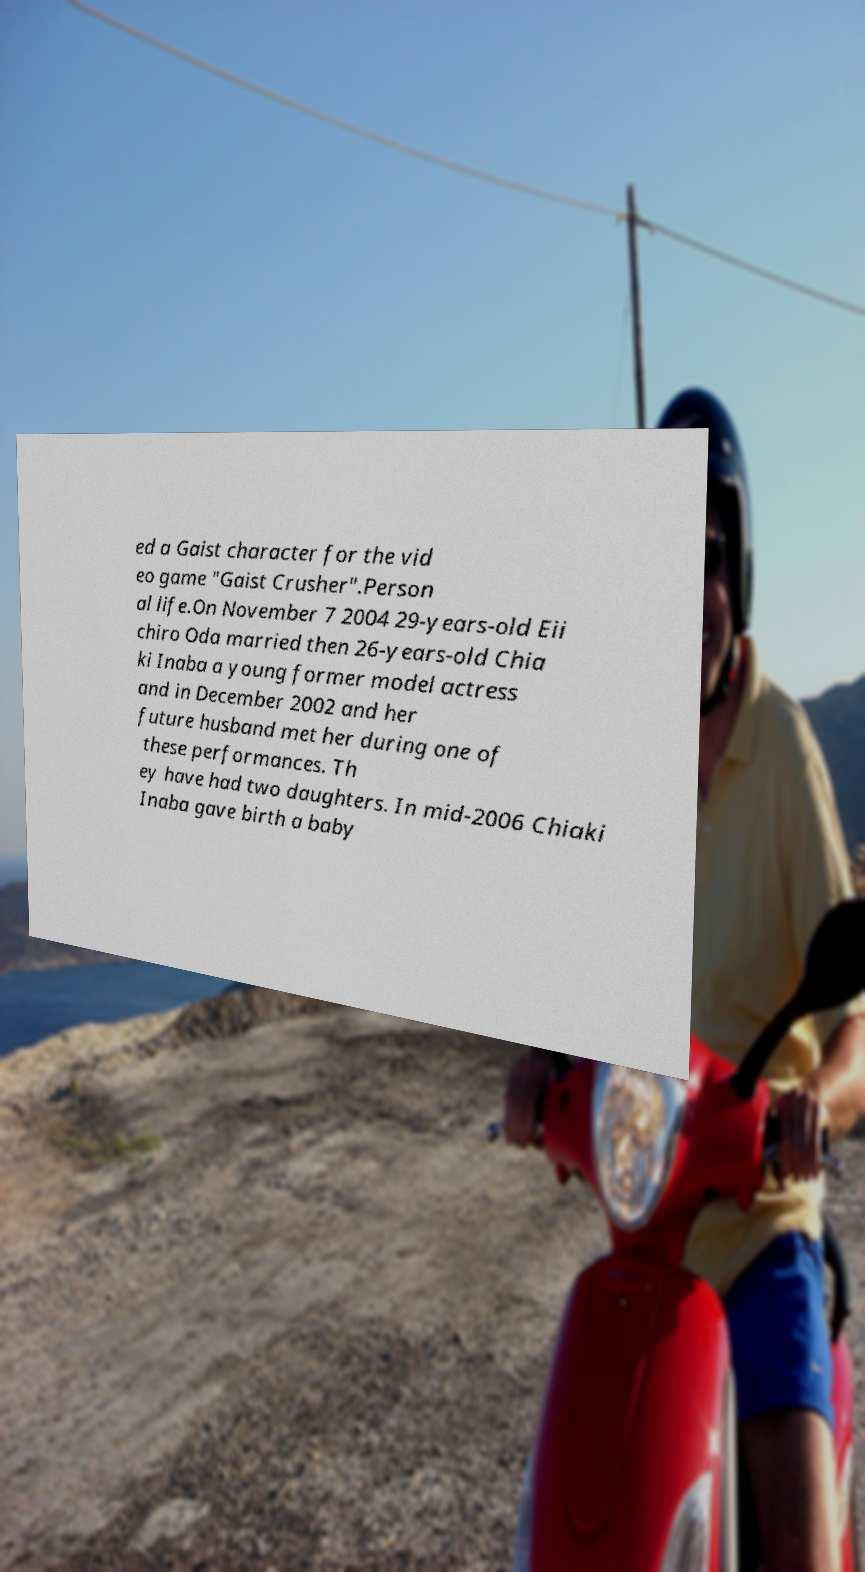Could you extract and type out the text from this image? ed a Gaist character for the vid eo game "Gaist Crusher".Person al life.On November 7 2004 29-years-old Eii chiro Oda married then 26-years-old Chia ki Inaba a young former model actress and in December 2002 and her future husband met her during one of these performances. Th ey have had two daughters. In mid-2006 Chiaki Inaba gave birth a baby 